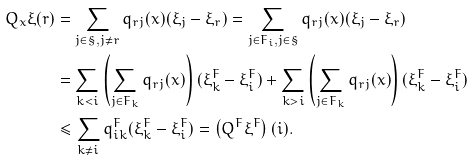<formula> <loc_0><loc_0><loc_500><loc_500>Q _ { x } \xi ( r ) & = \sum _ { j \in \S , j \neq r } q _ { r j } ( x ) ( \xi _ { j } - \xi _ { r } ) = \sum _ { j \in F _ { i } , j \in \S } q _ { r j } ( x ) ( \xi _ { j } - \xi _ { r } ) \\ & = \sum _ { k < i } \left ( \sum _ { j \in F _ { k } } q _ { r j } ( x ) \right ) ( \xi _ { k } ^ { F } - \xi _ { i } ^ { F } ) + \sum _ { k > i } \left ( \sum _ { j \in F _ { k } } q _ { r j } ( x ) \right ) ( \xi _ { k } ^ { F } - \xi _ { i } ^ { F } ) \\ & \leq \sum _ { k \neq i } q _ { i k } ^ { F } ( \xi _ { k } ^ { F } - \xi _ { i } ^ { F } ) = \left ( Q ^ { F } \xi ^ { F } \right ) ( i ) .</formula> 